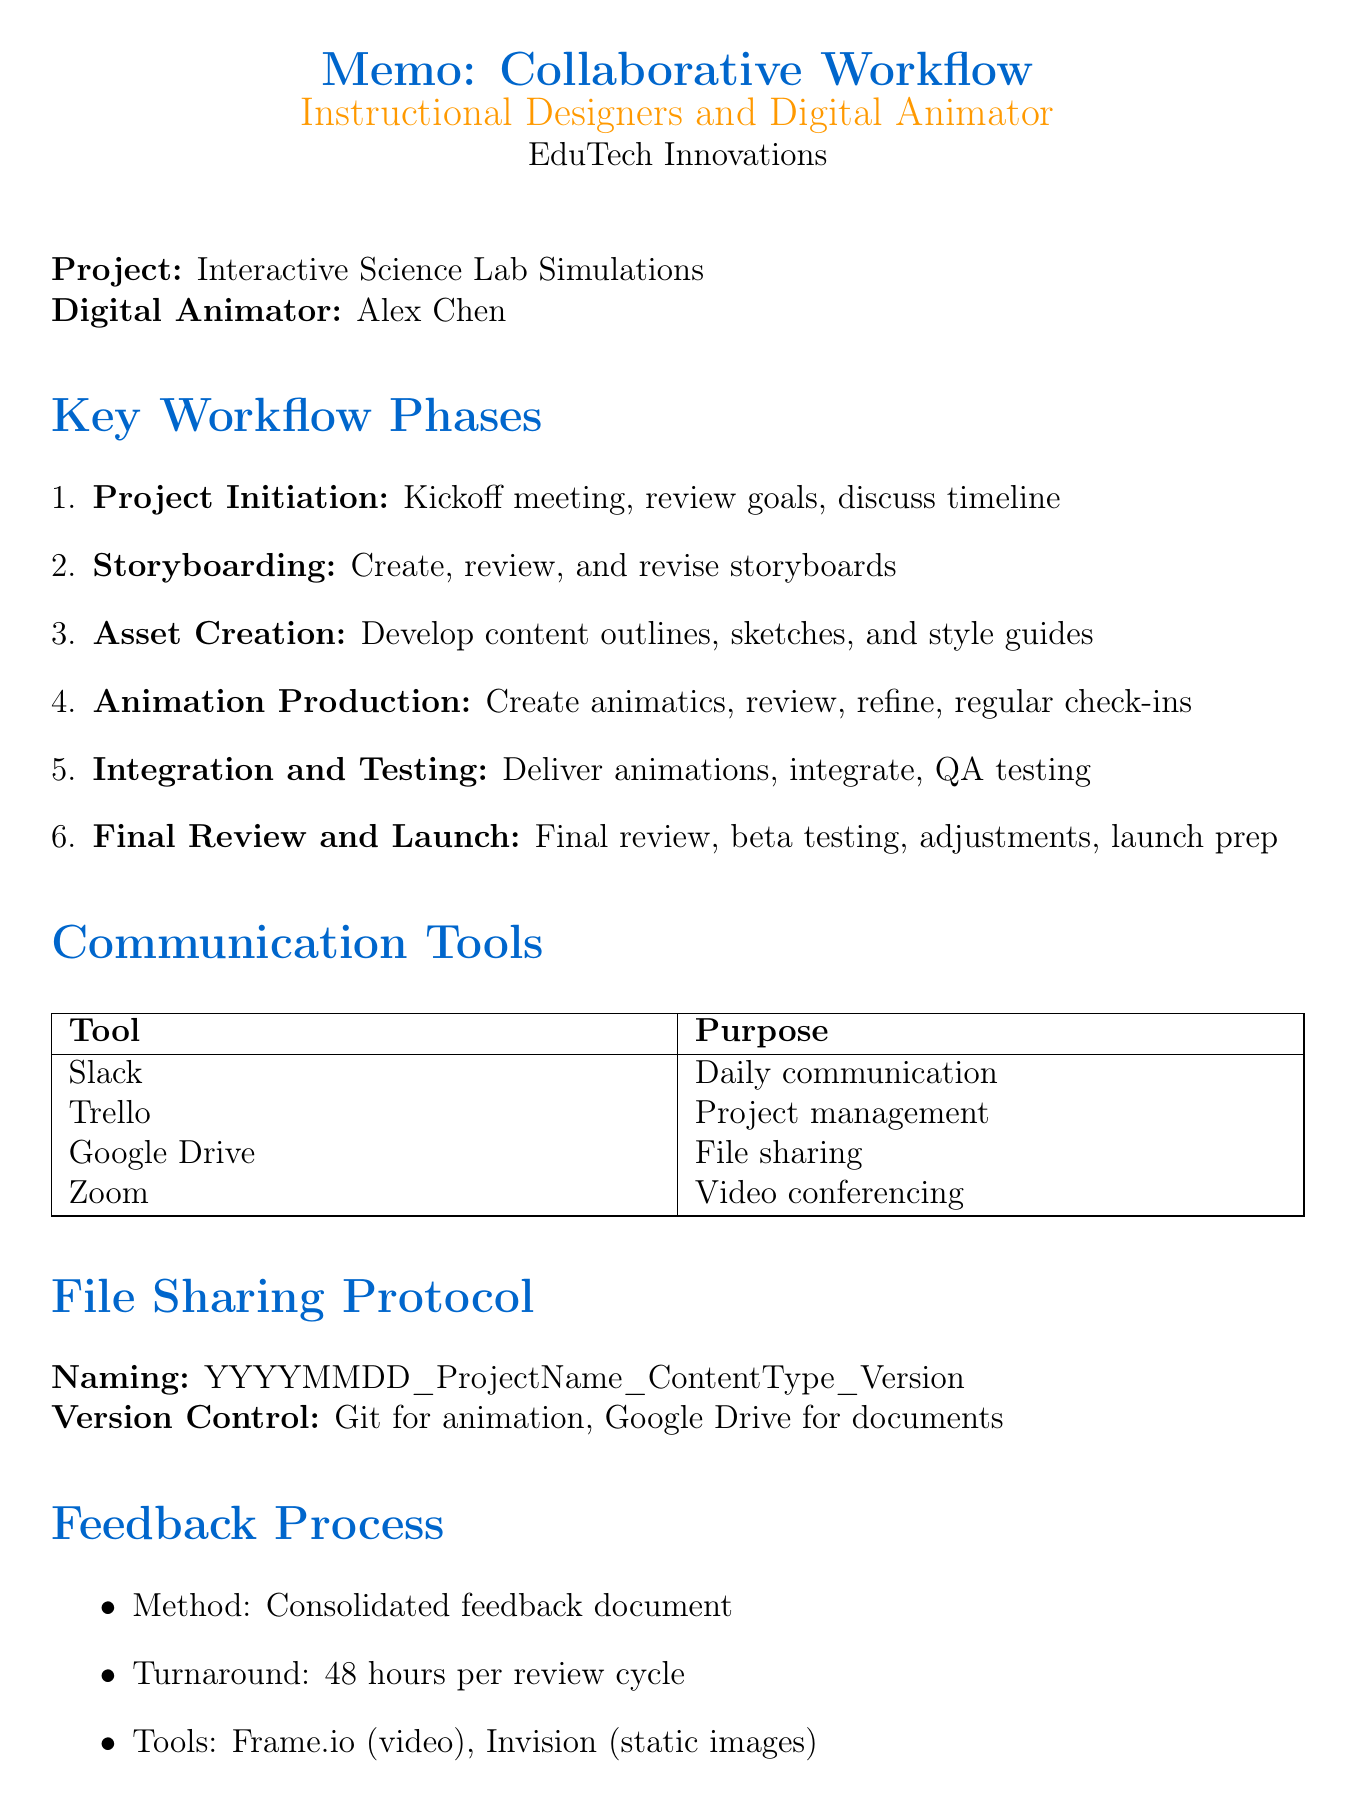what is the project name? The project name is stated in the document as "Interactive Science Lab Simulations."
Answer: Interactive Science Lab Simulations who is the digital animator? The digital animator's name is mentioned in the memo as "Alex Chen."
Answer: Alex Chen what is the deadline for the first animation draft? The deadline for the first animation draft is listed as "6 weeks from project start."
Answer: 6 weeks from project start what tool is used for project management? The tool designated for project management in the document is "Trello."
Answer: Trello how many review cycles are allowed before additional fees apply? The document indicates that "revisions beyond two rounds may incur extra charges."
Answer: two rounds what is the turnaround time for feedback? The turnaround time for feedback as outlined is "48 hours for each review cycle."
Answer: 48 hours during which phase do the instructional designers create initial storyboards? The phase where instructional designers create initial storyboards is referred to as "Storyboarding."
Answer: Storyboarding what is the payment schedule for the project? The payment schedule is detailed as "50% upfront, 25% at midpoint, 25% upon completion."
Answer: 50% upfront, 25% at midpoint, 25% upon completion what is the purpose of using Frame.io in the feedback process? Frame.io is used for "video annotations" within the feedback method described.
Answer: video annotations 